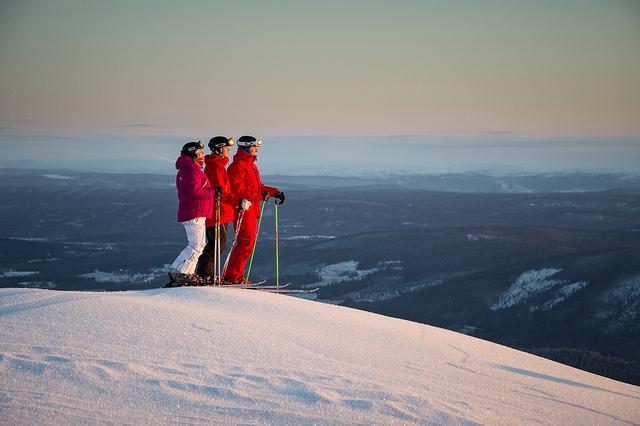Is she sliding down the hill?
Answer briefly. No. Are the men having fun?
Concise answer only. Yes. What is on the ground?
Answer briefly. Snow. Is the sun setting?
Quick response, please. Yes. Are these people moving?
Keep it brief. No. 